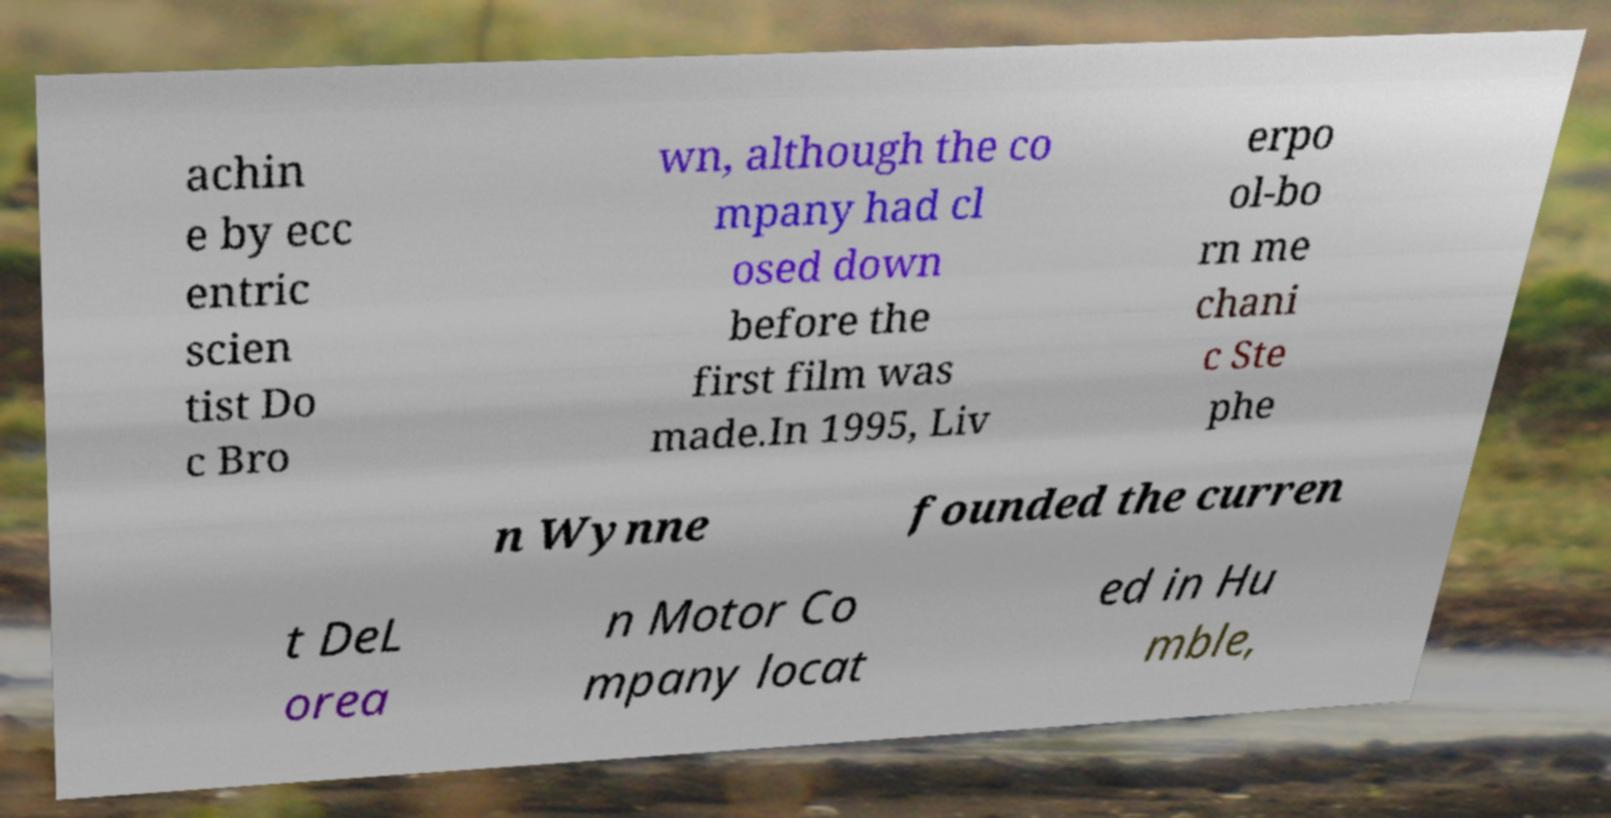Could you assist in decoding the text presented in this image and type it out clearly? achin e by ecc entric scien tist Do c Bro wn, although the co mpany had cl osed down before the first film was made.In 1995, Liv erpo ol-bo rn me chani c Ste phe n Wynne founded the curren t DeL orea n Motor Co mpany locat ed in Hu mble, 